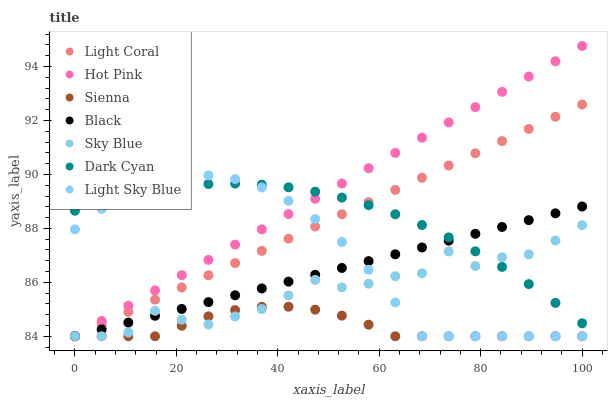Does Sienna have the minimum area under the curve?
Answer yes or no. Yes. Does Hot Pink have the maximum area under the curve?
Answer yes or no. Yes. Does Light Coral have the minimum area under the curve?
Answer yes or no. No. Does Light Coral have the maximum area under the curve?
Answer yes or no. No. Is Hot Pink the smoothest?
Answer yes or no. Yes. Is Sky Blue the roughest?
Answer yes or no. Yes. Is Light Coral the smoothest?
Answer yes or no. No. Is Light Coral the roughest?
Answer yes or no. No. Does Sienna have the lowest value?
Answer yes or no. Yes. Does Dark Cyan have the lowest value?
Answer yes or no. No. Does Hot Pink have the highest value?
Answer yes or no. Yes. Does Light Coral have the highest value?
Answer yes or no. No. Is Sienna less than Dark Cyan?
Answer yes or no. Yes. Is Dark Cyan greater than Sienna?
Answer yes or no. Yes. Does Light Coral intersect Sky Blue?
Answer yes or no. Yes. Is Light Coral less than Sky Blue?
Answer yes or no. No. Is Light Coral greater than Sky Blue?
Answer yes or no. No. Does Sienna intersect Dark Cyan?
Answer yes or no. No. 